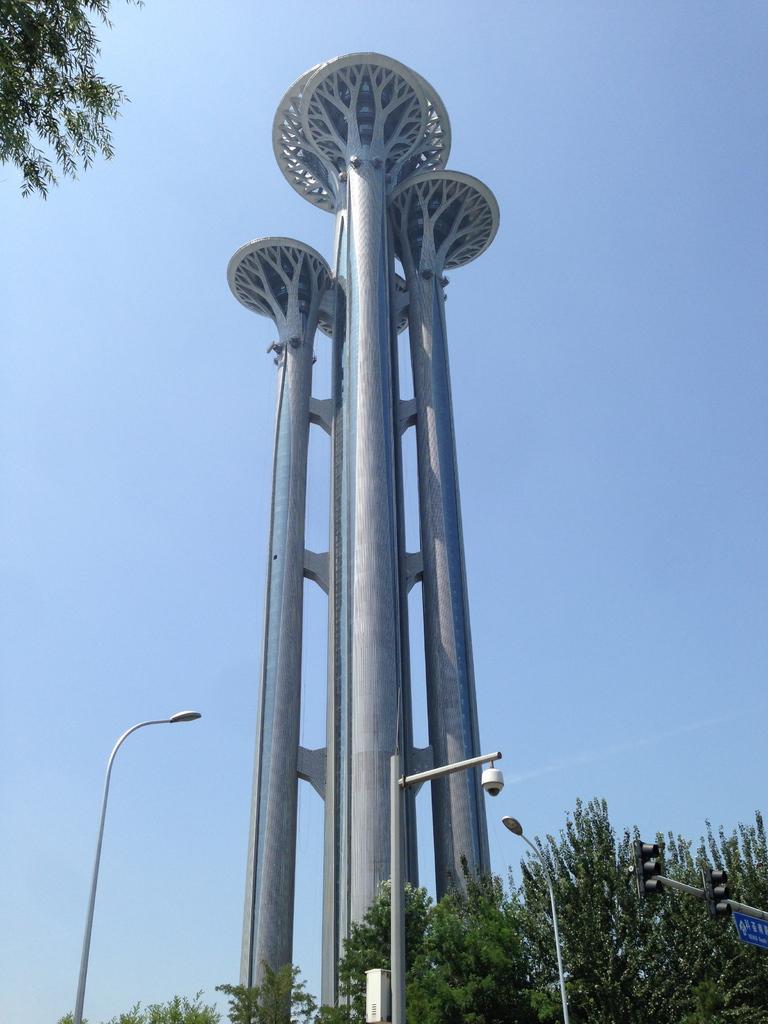Could you give a brief overview of what you see in this image? In the foreground of the picture there are trees, signal lights and street lights. In the center of the picture there is a tower. At the top left there are stems of a tree. Sky is clear and it is sunny. 